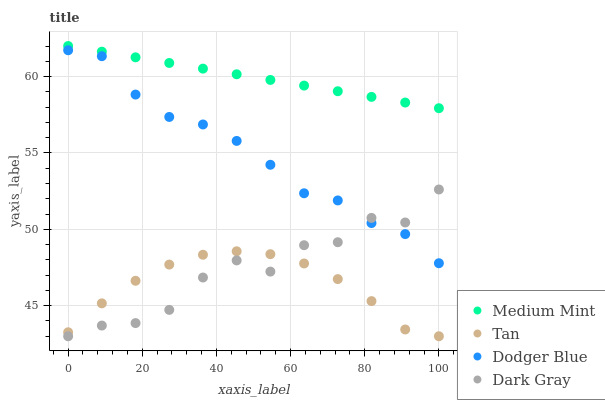Does Tan have the minimum area under the curve?
Answer yes or no. Yes. Does Medium Mint have the maximum area under the curve?
Answer yes or no. Yes. Does Dark Gray have the minimum area under the curve?
Answer yes or no. No. Does Dark Gray have the maximum area under the curve?
Answer yes or no. No. Is Medium Mint the smoothest?
Answer yes or no. Yes. Is Dark Gray the roughest?
Answer yes or no. Yes. Is Tan the smoothest?
Answer yes or no. No. Is Tan the roughest?
Answer yes or no. No. Does Dark Gray have the lowest value?
Answer yes or no. Yes. Does Dodger Blue have the lowest value?
Answer yes or no. No. Does Medium Mint have the highest value?
Answer yes or no. Yes. Does Dark Gray have the highest value?
Answer yes or no. No. Is Dark Gray less than Medium Mint?
Answer yes or no. Yes. Is Medium Mint greater than Tan?
Answer yes or no. Yes. Does Dark Gray intersect Dodger Blue?
Answer yes or no. Yes. Is Dark Gray less than Dodger Blue?
Answer yes or no. No. Is Dark Gray greater than Dodger Blue?
Answer yes or no. No. Does Dark Gray intersect Medium Mint?
Answer yes or no. No. 